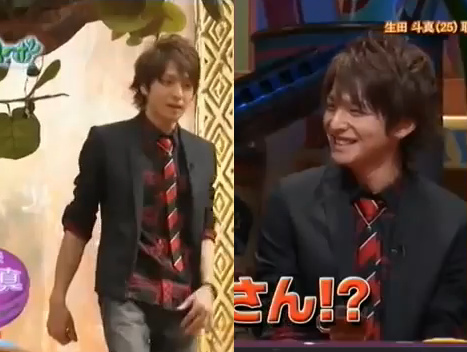Does the tie have striped pattern and purple color? No, the tie does not have a striped pattern or a purple color. 